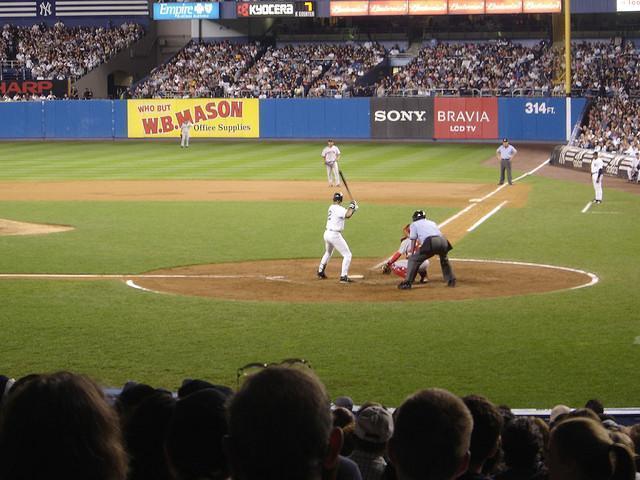How many people are in the photo?
Give a very brief answer. 7. 